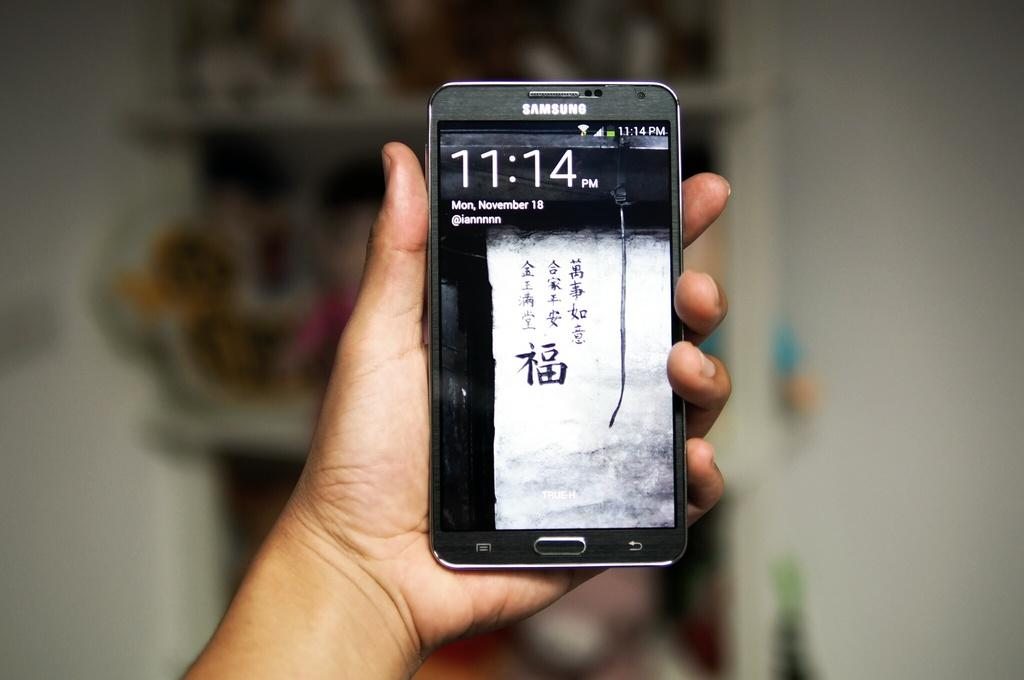<image>
Write a terse but informative summary of the picture. A phone in a person's hand displays the time of 11:14. 